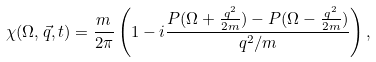<formula> <loc_0><loc_0><loc_500><loc_500>\chi ( \Omega , \vec { q } , t ) = \frac { m } { 2 \pi } \left ( 1 - i \frac { P ( \Omega + \frac { q ^ { 2 } } { 2 m } ) - P ( \Omega - \frac { q ^ { 2 } } { 2 m } ) } { q ^ { 2 } / m } \right ) ,</formula> 